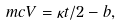Convert formula to latex. <formula><loc_0><loc_0><loc_500><loc_500>\ m c { V } = \kappa t / 2 - b ,</formula> 